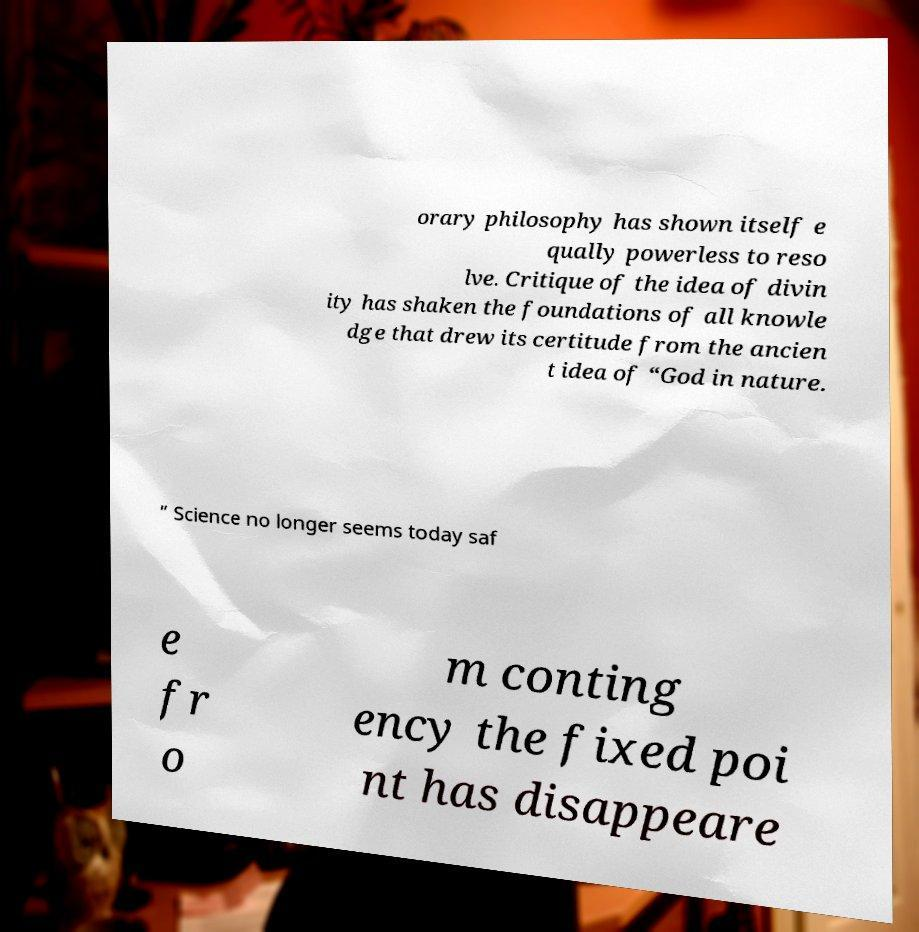Could you extract and type out the text from this image? orary philosophy has shown itself e qually powerless to reso lve. Critique of the idea of divin ity has shaken the foundations of all knowle dge that drew its certitude from the ancien t idea of “God in nature. ” Science no longer seems today saf e fr o m conting ency the fixed poi nt has disappeare 